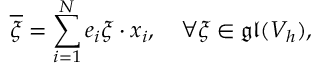Convert formula to latex. <formula><loc_0><loc_0><loc_500><loc_500>\overline { \xi } = \sum _ { i = 1 } ^ { N } e _ { i } \xi \cdot x _ { i } , \quad \forall \xi \in \mathfrak { g l } ( V _ { h } ) ,</formula> 